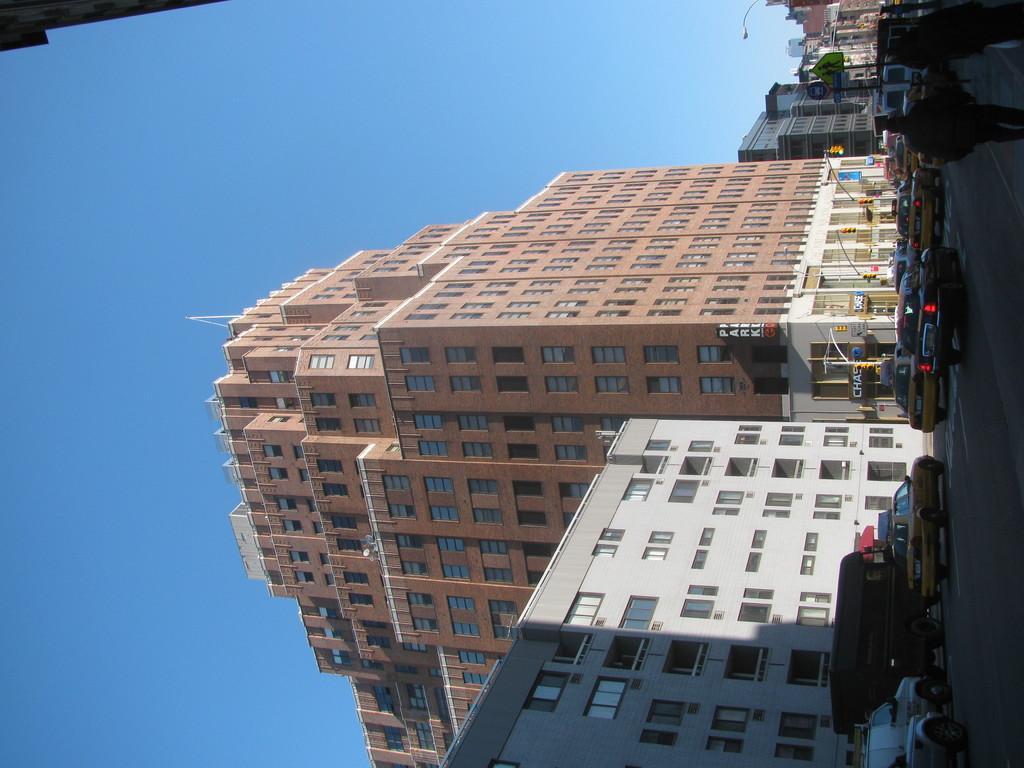Can you describe this image briefly? On the right side of the image there is a road and we can see cars on the road. There are people walking. In the center there are buildings. In the background there is sky. 